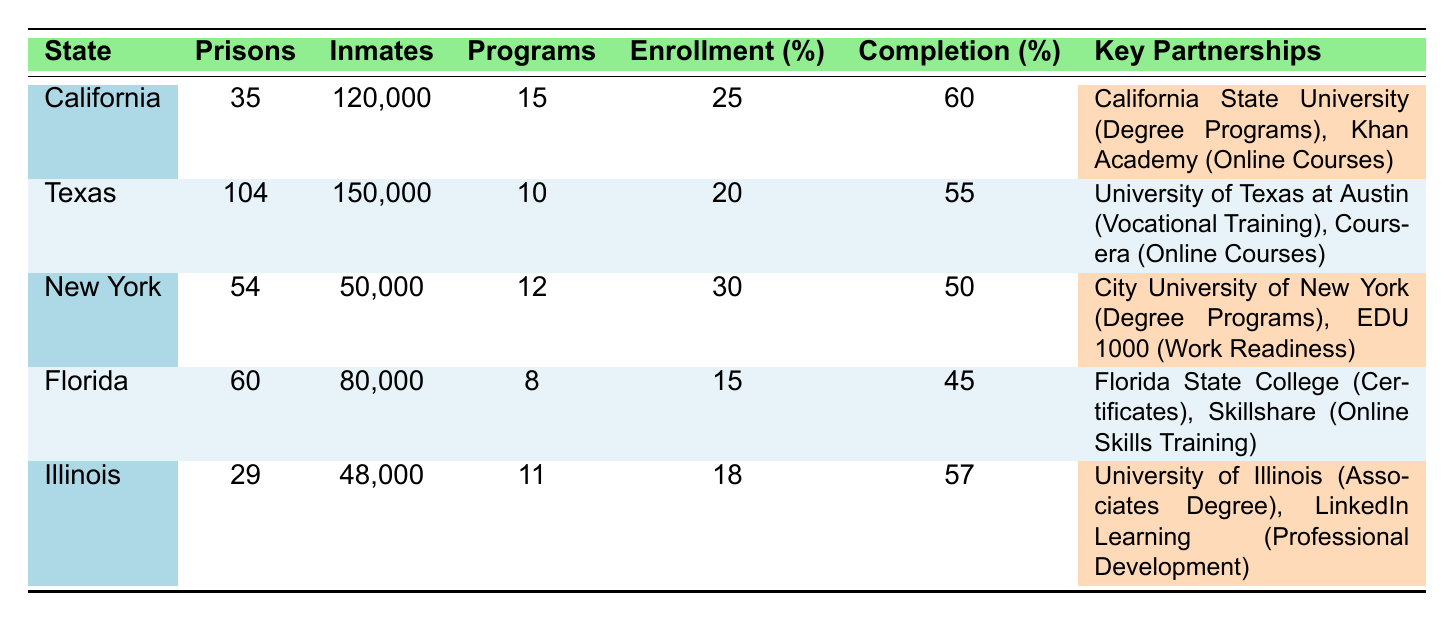What state has the highest enrollment rate in educational programs? By examining the enrollment rates provided in the table, California has an enrollment rate of 25%, Texas has 20%, New York has 30%, Florida has 15%, and Illinois has 18%. New York has the highest rate of 30%.
Answer: New York Which state offers the fewest number of educational programs? The table lists the number of programs offered for each state: California with 15, Texas with 10, New York with 12, Florida with 8, and Illinois with 11. Florida offers the fewest programs with 8.
Answer: Florida What is the total number of inmates across all states? To find the total number of inmates, sum the number of inmates from each state: 120,000 (California) + 150,000 (Texas) + 50,000 (New York) + 80,000 (Florida) + 48,000 (Illinois) = 448,000.
Answer: 448,000 Is the completion rate in Texas higher than in California? The completion rates are 60% for California and 55% for Texas. Since 60% is greater than 55%, the statement is true.
Answer: Yes What is the average completion rate across all states? To find the average completion rate, add the completion rates: 60 + 55 + 50 + 45 + 57 = 267. Then divide by the number of states (5): 267 / 5 = 53.4.
Answer: 53.4 Does Florida have more prisons than Illinois? Florida has 60 prisons while Illinois has 29 prisons. Therefore, Florida has more prisons than Illinois.
Answer: Yes What is the difference in enrollment rates between the states with the highest and lowest rates? The highest enrollment rate is 30% (New York) and the lowest is 15% (Florida). The difference is calculated as 30% - 15% = 15%.
Answer: 15% Which states have partnerships for online courses? The table shows that California partners with Khan Academy for online courses and Texas partners with Coursera for online courses. Thus, California and Texas have partnerships for online courses.
Answer: California and Texas What is the total number of educational programs in the two states with the most prisons? Texas has 10 programs and California has 15 programs. The total is 10 + 15 = 25 programs.
Answer: 25 Which state has the highest number of total inmates and what is that number? Texas has the highest number of total inmates at 150,000.
Answer: Texas, 150,000 